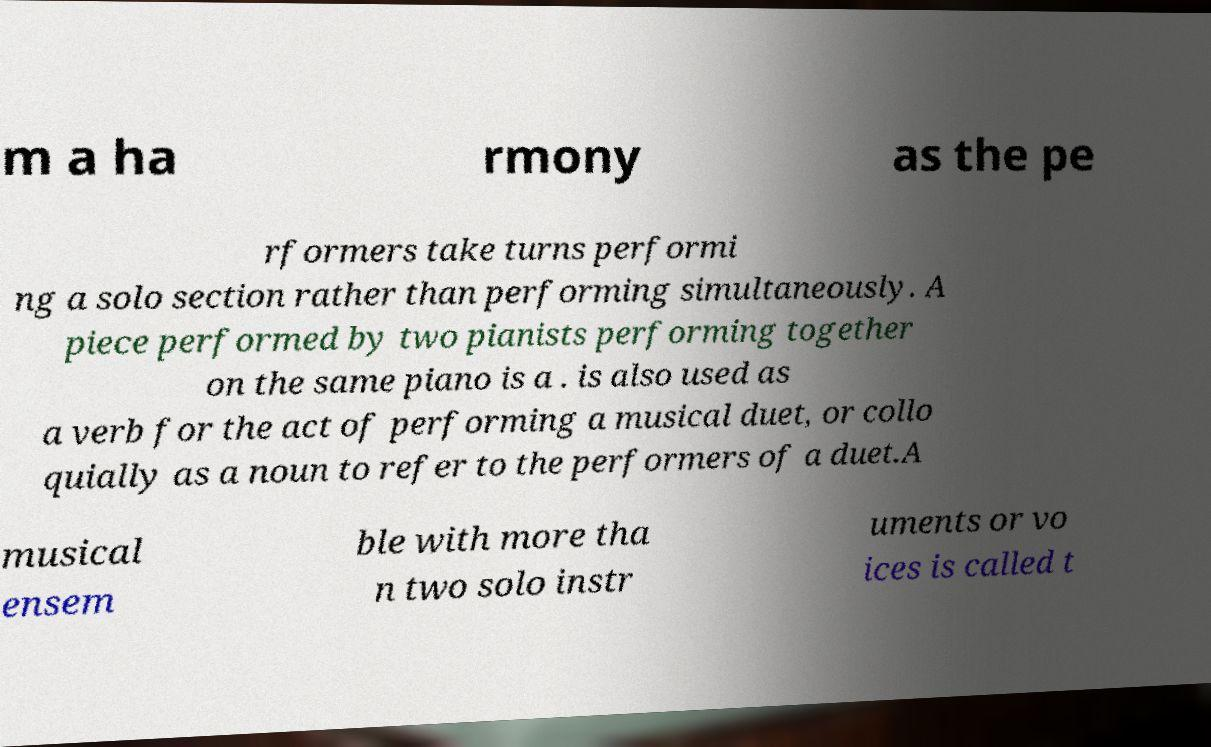I need the written content from this picture converted into text. Can you do that? m a ha rmony as the pe rformers take turns performi ng a solo section rather than performing simultaneously. A piece performed by two pianists performing together on the same piano is a . is also used as a verb for the act of performing a musical duet, or collo quially as a noun to refer to the performers of a duet.A musical ensem ble with more tha n two solo instr uments or vo ices is called t 